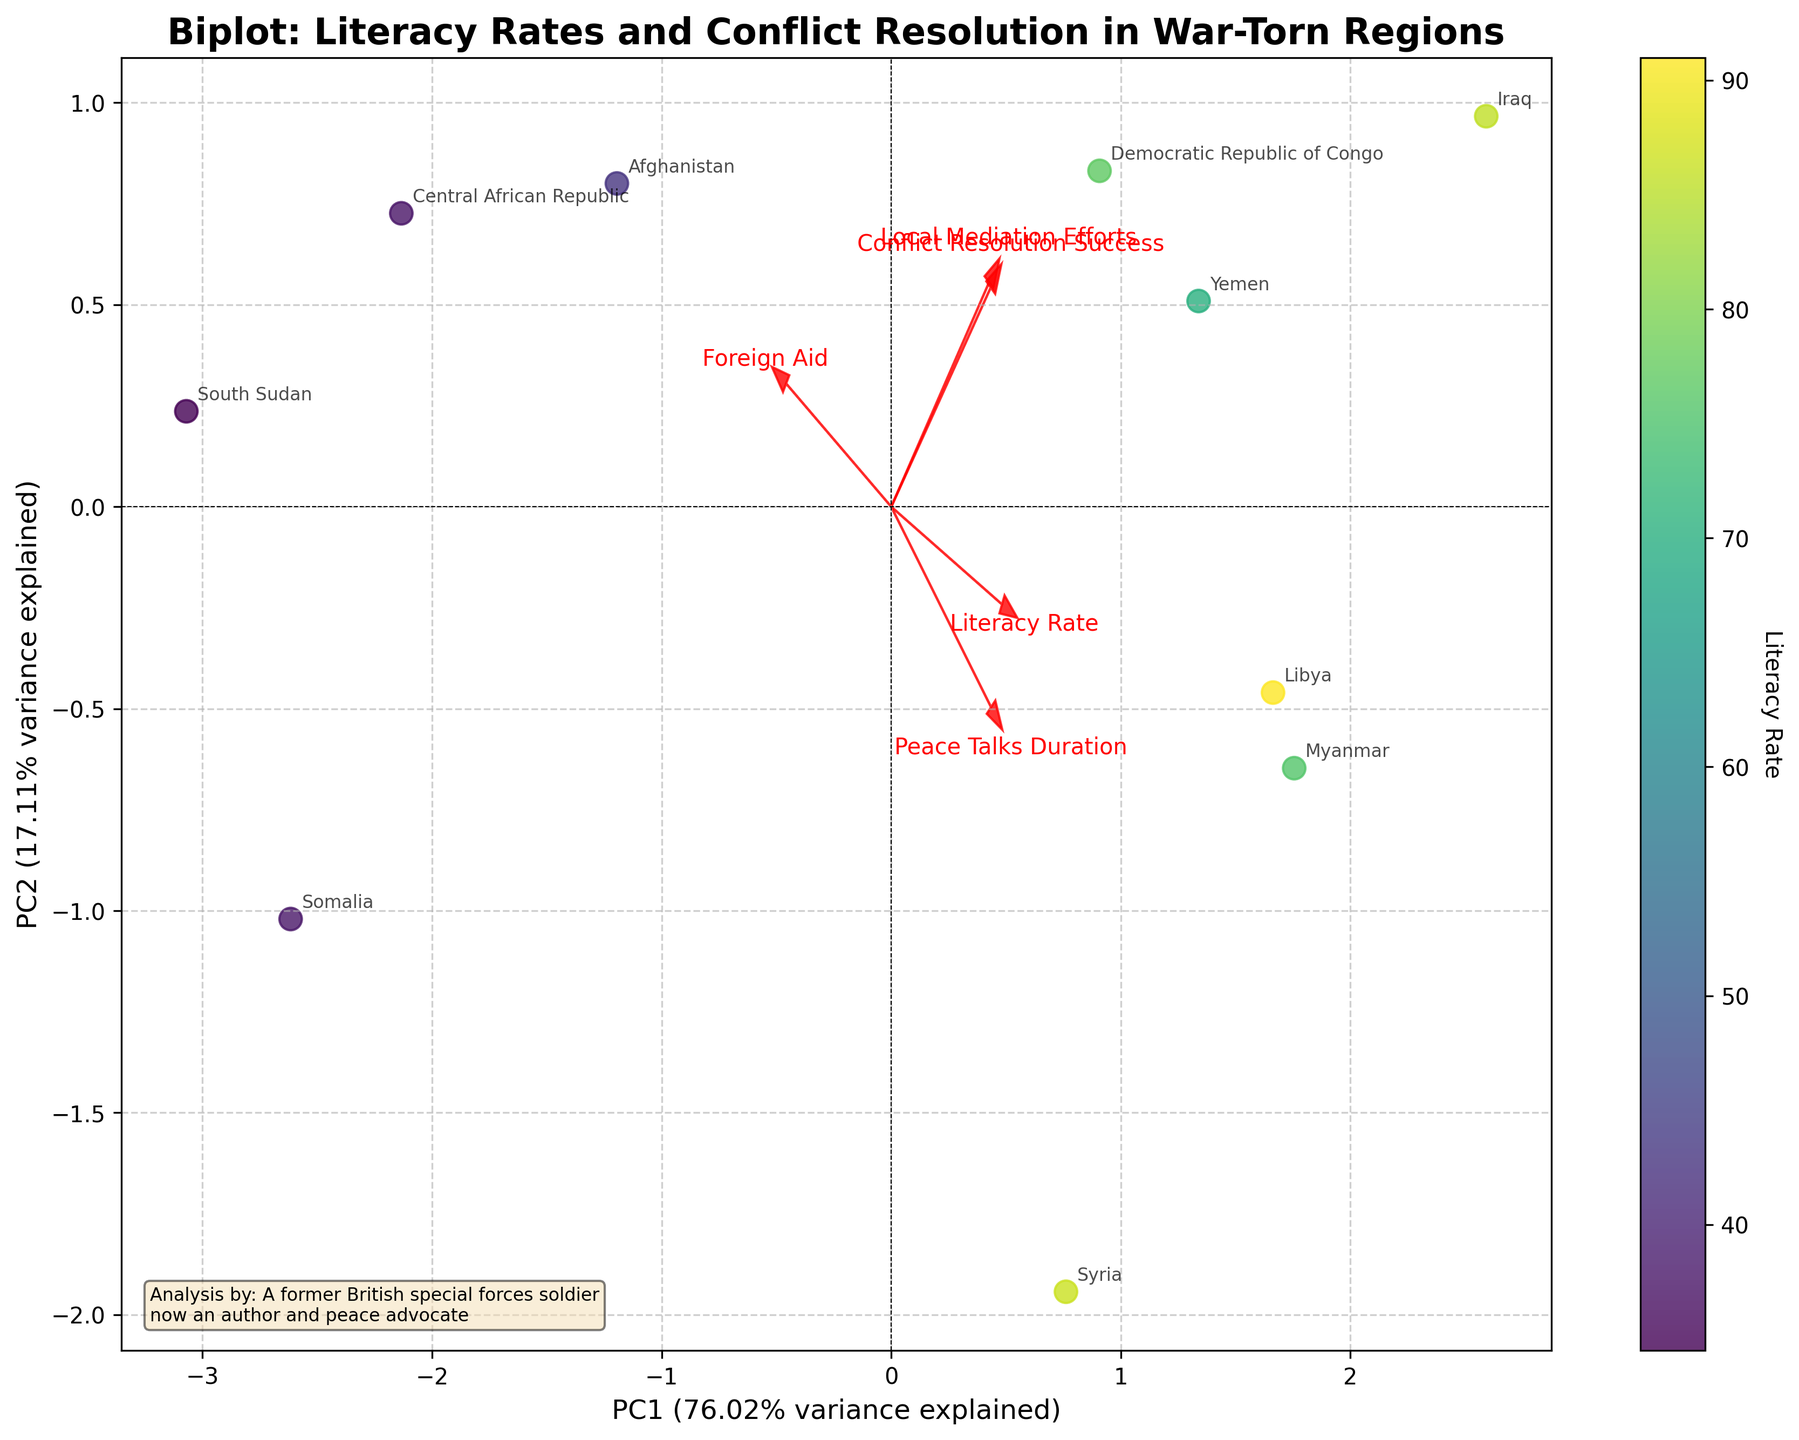How are the Literacy Rate and Conflict Resolution Success variables represented on the plot? In a Biplot, the principal components are represented on the axes (PC1 and PC2). The arrows and labels indicate the direction and influence of original variables such as Literacy Rate and Conflict Resolution Success on these principal components.
Answer: Arrows and labels Which country has the highest Literacy Rate? The Biplot uses color to represent Literacy Rate, with darker colors indicating higher rates. Observing the plot, Libya is the country represented with the darkest color, indicating that it has the highest Literacy Rate.
Answer: Libya Which principal component (PC) explains more variance? The variance explained by each principal component is indicated on the axes labels in percentage. From the plot, PC1 has a variance explanation of a higher percentage compared to PC2.
Answer: PC1 How many data points are represented in the Biplot? Each country represents a single data point on the Biplot. Counting the number of distinct labeled points gives us the total number of data points. From the plot, there are 10 data points representing 10 countries.
Answer: 10 Which features have the strongest influence on PC1 and PC2 respectively? To identify the features with the strongest influence on PC1 and PC2, observe the length and direction of the arrows along each principal component. The arrow with the longest projection on the PC1 axis indicates the strongest influence on PC1, and similarly for PC2.
Answer: PC1: Literacy Rate, PC2: Peace Talks Duration How is Local Mediation Efforts represented visually, and what does an arrow pointing towards the upper right quadrant indicate for this variable? Local Mediation Efforts, like all other features, is represented by an arrow on the Biplot. An arrow pointing towards the upper right quadrant indicates a positive correlation with both PC1 and PC2, suggesting that as Local Mediation Efforts increase, the values for both principal components also increase.
Answer: Arrow, Positive correlation What can be inferred about the relationship between Literacy Rate and Conflict Resolution Success in this plot? Observing the Biplot, the arrows representing Literacy Rate and Conflict Resolution Success do not point in identical directions. This suggests that while there may be some degree of correlation due to the Biplot's clustering, it is not perfectly linear or direct. Further detailed data analysis would be required to clarify this relationship.
Answer: Not perfectly correlated Which country appears to have the highest Conflict Resolution Success based on its position relative to the dimensionality reduction? Analyzing the Biplot, the dimensions reduced for Conflict Resolution Success can be inferred from its arrow direction and closest countries. Iraq appears to be positioned closest, indicating the highest Conflict Resolution Success.
Answer: Iraq 